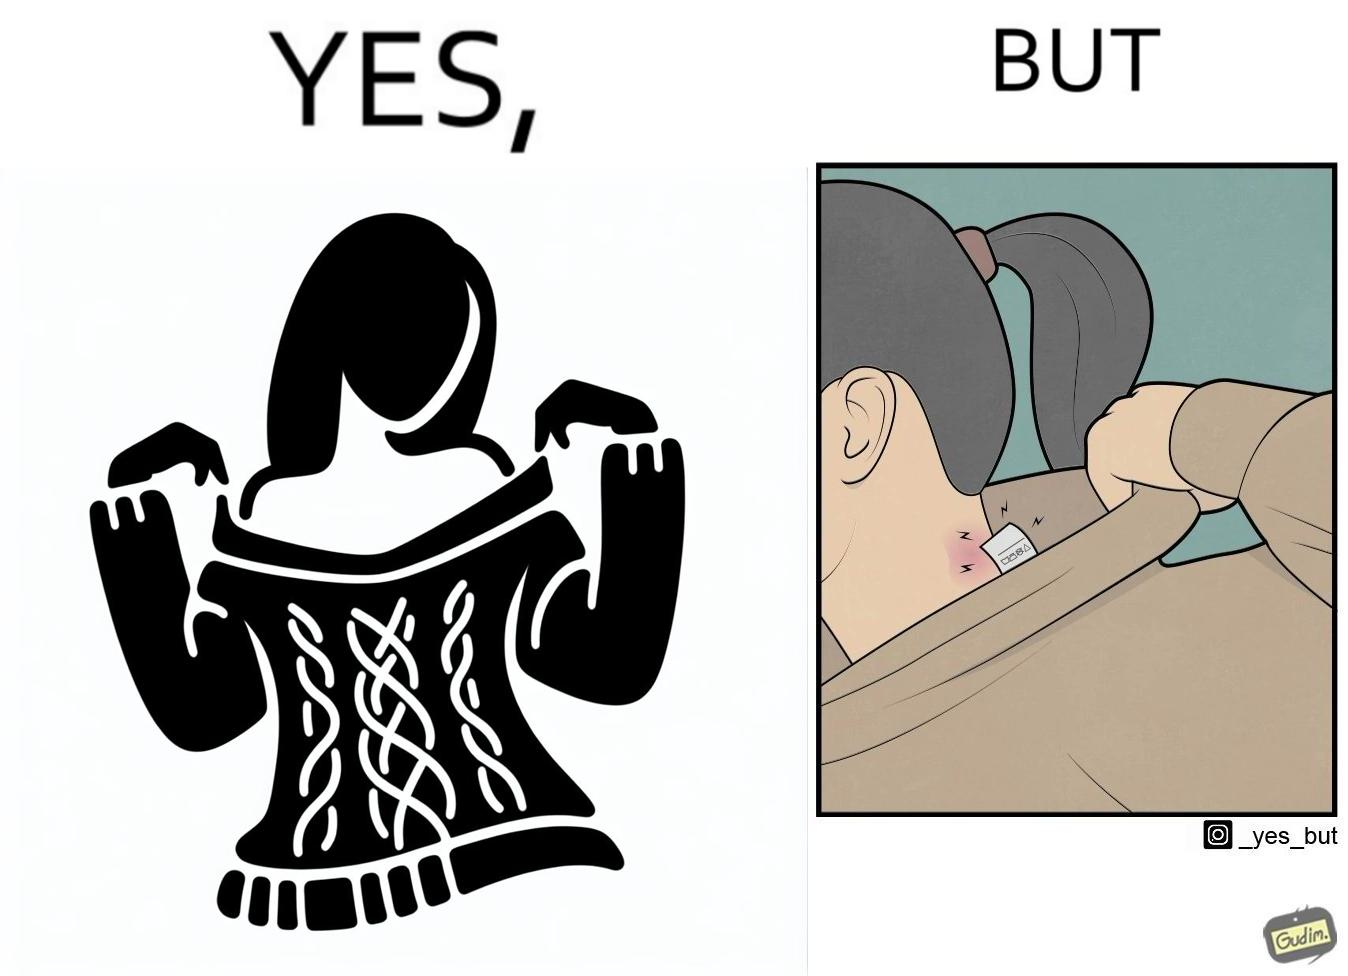What do you see in each half of this image? In the left part of the image: It is a woman enjoying the warmth and comfort of her sweater In the right part of the image: It a womans neck, irritated and red due to manufacturers tags on her clothes 